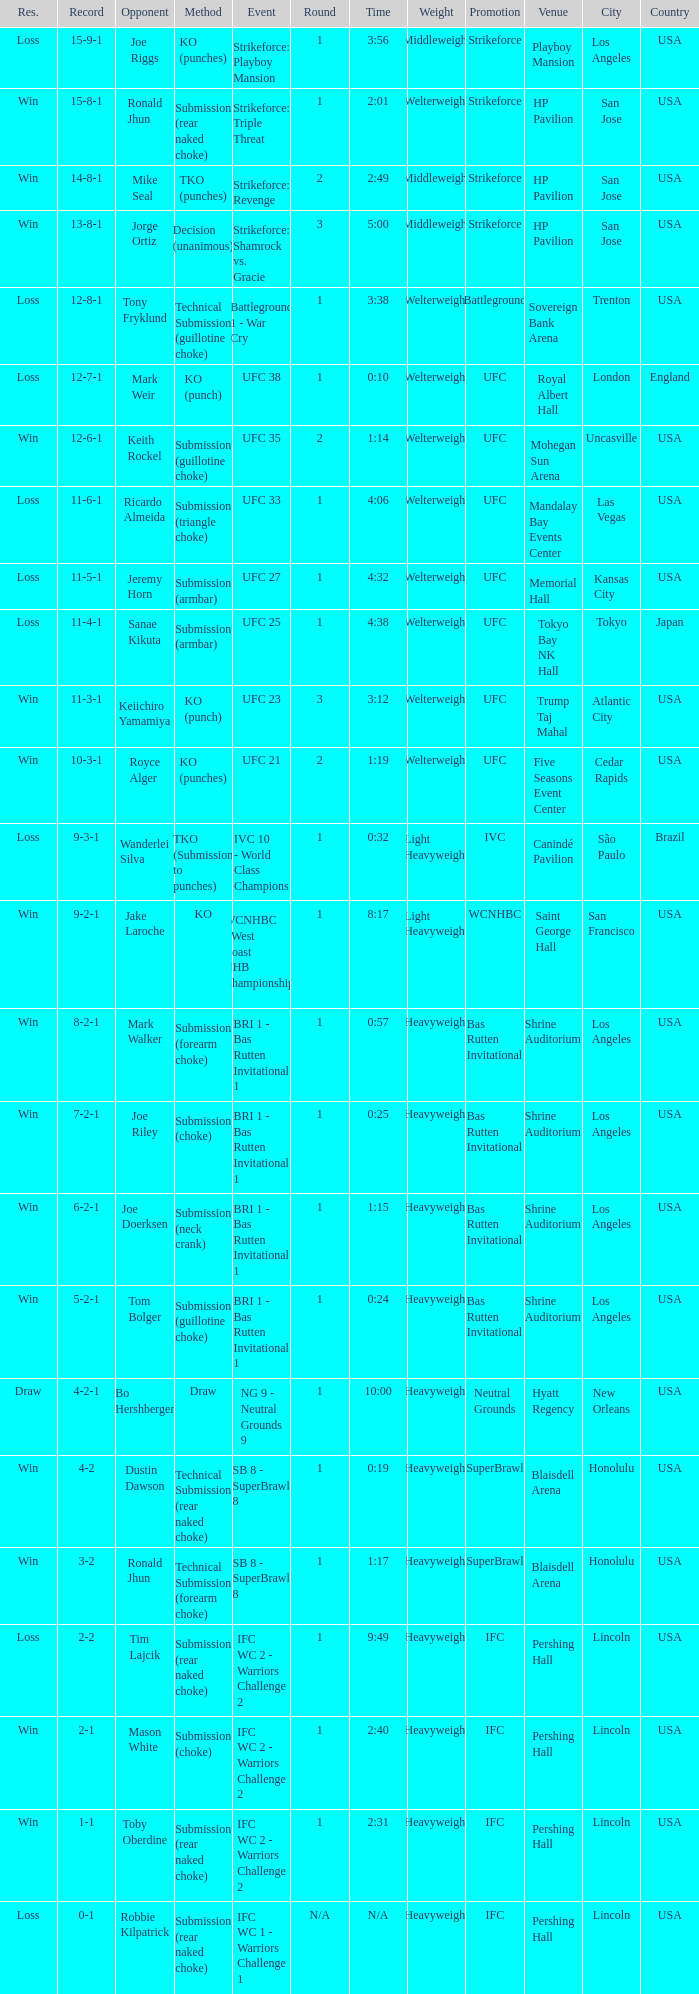What is the record during the event, UFC 27? 11-5-1. Can you parse all the data within this table? {'header': ['Res.', 'Record', 'Opponent', 'Method', 'Event', 'Round', 'Time', 'Weight', 'Promotion', 'Venue', 'City', 'Country'], 'rows': [['Loss', '15-9-1', 'Joe Riggs', 'KO (punches)', 'Strikeforce: Playboy Mansion', '1', '3:56', 'Middleweight', 'Strikeforce', 'Playboy Mansion', 'Los Angeles', 'USA'], ['Win', '15-8-1', 'Ronald Jhun', 'Submission (rear naked choke)', 'Strikeforce: Triple Threat', '1', '2:01', 'Welterweight', 'Strikeforce', 'HP Pavilion', 'San Jose', 'USA'], ['Win', '14-8-1', 'Mike Seal', 'TKO (punches)', 'Strikeforce: Revenge', '2', '2:49', 'Middleweight', 'Strikeforce', 'HP Pavilion', 'San Jose', 'USA'], ['Win', '13-8-1', 'Jorge Ortiz', 'Decision (unanimous)', 'Strikeforce: Shamrock vs. Gracie', '3', '5:00', 'Middleweight', 'Strikeforce', 'HP Pavilion', 'San Jose', 'USA'], ['Loss', '12-8-1', 'Tony Fryklund', 'Technical Submission (guillotine choke)', 'Battleground 1 - War Cry', '1', '3:38', 'Welterweight', 'Battleground', 'Sovereign Bank Arena', 'Trenton', 'USA'], ['Loss', '12-7-1', 'Mark Weir', 'KO (punch)', 'UFC 38', '1', '0:10', 'Welterweight', 'UFC', 'Royal Albert Hall', 'London', 'England'], ['Win', '12-6-1', 'Keith Rockel', 'Submission (guillotine choke)', 'UFC 35', '2', '1:14', 'Welterweight', 'UFC', 'Mohegan Sun Arena', 'Uncasville', 'USA'], ['Loss', '11-6-1', 'Ricardo Almeida', 'Submission (triangle choke)', 'UFC 33', '1', '4:06', 'Welterweight', 'UFC', 'Mandalay Bay Events Center', 'Las Vegas', 'USA'], ['Loss', '11-5-1', 'Jeremy Horn', 'Submission (armbar)', 'UFC 27', '1', '4:32', 'Welterweight', 'UFC', 'Memorial Hall', 'Kansas City', 'USA'], ['Loss', '11-4-1', 'Sanae Kikuta', 'Submission (armbar)', 'UFC 25', '1', '4:38', 'Welterweight', 'UFC', 'Tokyo Bay NK Hall', 'Tokyo', 'Japan'], ['Win', '11-3-1', 'Keiichiro Yamamiya', 'KO (punch)', 'UFC 23', '3', '3:12', 'Welterweight', 'UFC', 'Trump Taj Mahal', 'Atlantic City', 'USA'], ['Win', '10-3-1', 'Royce Alger', 'KO (punches)', 'UFC 21', '2', '1:19', 'Welterweight', 'UFC', 'Five Seasons Event Center', 'Cedar Rapids', 'USA'], ['Loss', '9-3-1', 'Wanderlei Silva', 'TKO (Submission to punches)', 'IVC 10 - World Class Champions', '1', '0:32', 'Light Heavyweight', 'IVC', 'Canindé Pavilion', 'São Paulo', 'Brazil'], ['Win', '9-2-1', 'Jake Laroche', 'KO', 'WCNHBC - West Coast NHB Championships 2', '1', '8:17', 'Light Heavyweight', 'WCNHBC', 'Saint George Hall', 'San Francisco', 'USA'], ['Win', '8-2-1', 'Mark Walker', 'Submission (forearm choke)', 'BRI 1 - Bas Rutten Invitational 1', '1', '0:57', 'Heavyweight', 'Bas Rutten Invitational', 'Shrine Auditorium', 'Los Angeles', 'USA'], ['Win', '7-2-1', 'Joe Riley', 'Submission (choke)', 'BRI 1 - Bas Rutten Invitational 1', '1', '0:25', 'Heavyweight', 'Bas Rutten Invitational', 'Shrine Auditorium', 'Los Angeles', 'USA'], ['Win', '6-2-1', 'Joe Doerksen', 'Submission (neck crank)', 'BRI 1 - Bas Rutten Invitational 1', '1', '1:15', 'Heavyweight', 'Bas Rutten Invitational', 'Shrine Auditorium', 'Los Angeles', 'USA'], ['Win', '5-2-1', 'Tom Bolger', 'Submission (guillotine choke)', 'BRI 1 - Bas Rutten Invitational 1', '1', '0:24', 'Heavyweight', 'Bas Rutten Invitational', 'Shrine Auditorium', 'Los Angeles', 'USA'], ['Draw', '4-2-1', 'Bo Hershberger', 'Draw', 'NG 9 - Neutral Grounds 9', '1', '10:00', 'Heavyweight', 'Neutral Grounds', 'Hyatt Regency', 'New Orleans', 'USA'], ['Win', '4-2', 'Dustin Dawson', 'Technical Submission (rear naked choke)', 'SB 8 - SuperBrawl 8', '1', '0:19', 'Heavyweight', 'SuperBrawl', 'Blaisdell Arena', 'Honolulu', 'USA'], ['Win', '3-2', 'Ronald Jhun', 'Technical Submission (forearm choke)', 'SB 8 - SuperBrawl 8', '1', '1:17', 'Heavyweight', 'SuperBrawl', 'Blaisdell Arena', 'Honolulu', 'USA'], ['Loss', '2-2', 'Tim Lajcik', 'Submission (rear naked choke)', 'IFC WC 2 - Warriors Challenge 2', '1', '9:49', 'Heavyweight', 'IFC', 'Pershing Hall', 'Lincoln', 'USA'], ['Win', '2-1', 'Mason White', 'Submission (choke)', 'IFC WC 2 - Warriors Challenge 2', '1', '2:40', 'Heavyweight', 'IFC', 'Pershing Hall', 'Lincoln', 'USA'], ['Win', '1-1', 'Toby Oberdine', 'Submission (rear naked choke)', 'IFC WC 2 - Warriors Challenge 2', '1', '2:31', 'Heavyweight', 'IFC', 'Pershing Hall', 'Lincoln', 'USA'], ['Loss', '0-1', 'Robbie Kilpatrick', 'Submission (rear naked choke)', 'IFC WC 1 - Warriors Challenge 1', 'N/A', 'N/A', 'Heavyweight', 'IFC', 'Pershing Hall', 'Lincoln', 'USA']]} 